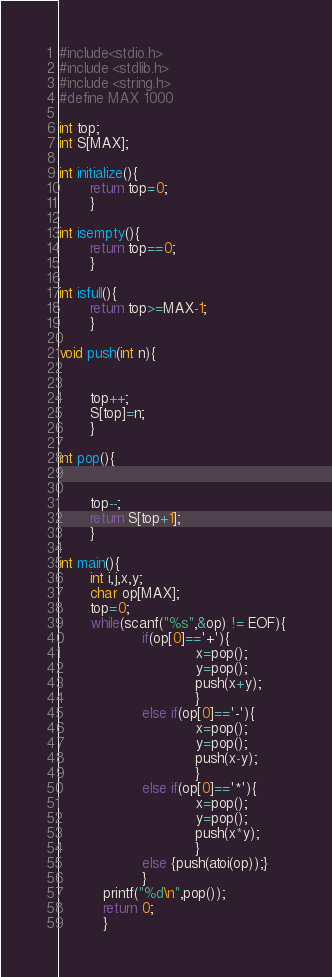Convert code to text. <code><loc_0><loc_0><loc_500><loc_500><_C_>#include<stdio.h>
#include <stdlib.h>
#include <string.h>
#define MAX 1000

int top;
int S[MAX];

int initialize(){
       return top=0;
       }

int isempty(){
       return top==0;
       }

int isfull(){
       return top>=MAX-1;
       }

void push(int n){


       top++;
       S[top]=n;
       }

int pop(){


       top--;
       return S[top+1];
       }

int main(){
       int i,j,x,y;
       char op[MAX];
       top=0;
       while(scanf("%s",&op) != EOF){
                   if(op[0]=='+'){
                               x=pop();
                               y=pop();
                               push(x+y);
                               }
                   else if(op[0]=='-'){
                               x=pop();
                               y=pop();
                               push(x-y);
                               }
                   else if(op[0]=='*'){
                               x=pop();
                               y=pop();
                               push(x*y);
                               }
                   else {push(atoi(op));}
                   }
          printf("%d\n",pop());
          return 0;
          }


</code> 